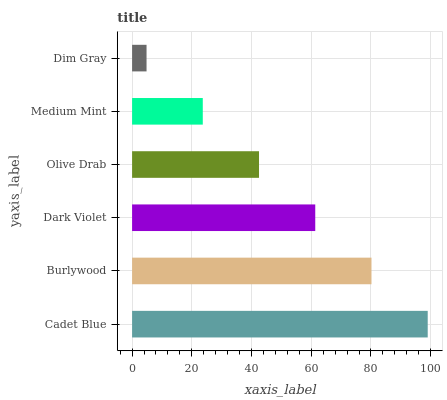Is Dim Gray the minimum?
Answer yes or no. Yes. Is Cadet Blue the maximum?
Answer yes or no. Yes. Is Burlywood the minimum?
Answer yes or no. No. Is Burlywood the maximum?
Answer yes or no. No. Is Cadet Blue greater than Burlywood?
Answer yes or no. Yes. Is Burlywood less than Cadet Blue?
Answer yes or no. Yes. Is Burlywood greater than Cadet Blue?
Answer yes or no. No. Is Cadet Blue less than Burlywood?
Answer yes or no. No. Is Dark Violet the high median?
Answer yes or no. Yes. Is Olive Drab the low median?
Answer yes or no. Yes. Is Cadet Blue the high median?
Answer yes or no. No. Is Burlywood the low median?
Answer yes or no. No. 